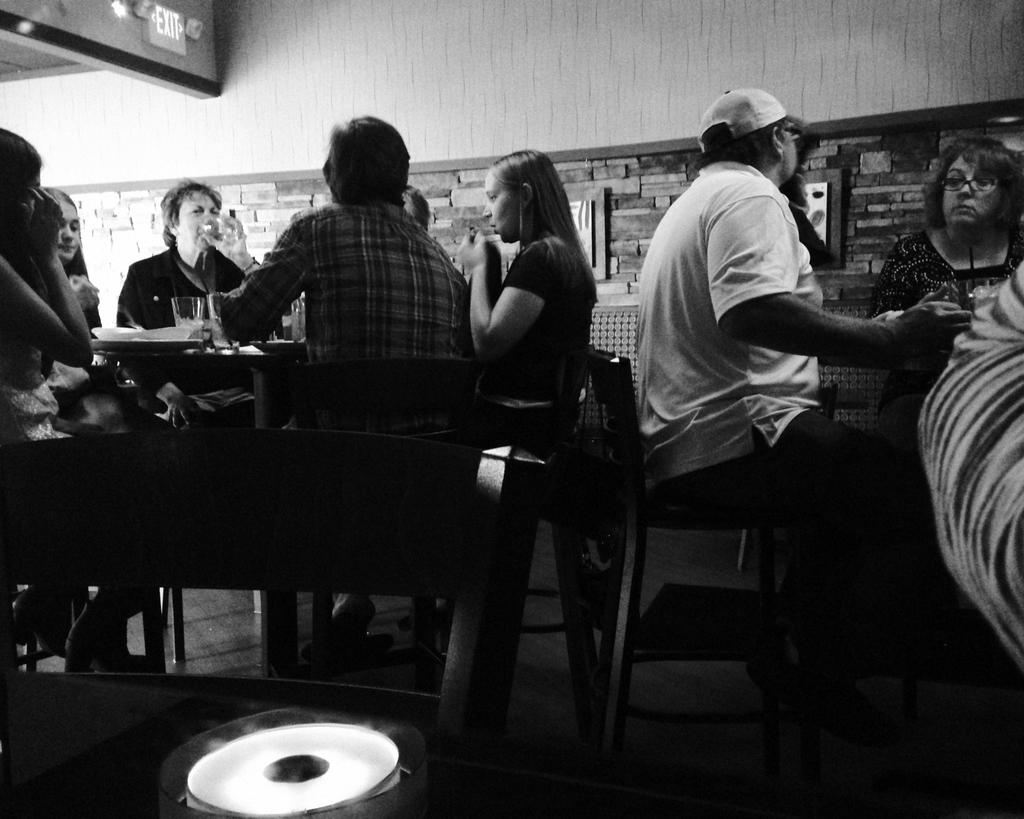What is happening in the image involving a group of people? There is a group of people in the image, and they are seated on chairs. Can you describe any specific actions being performed by someone in the image? Yes, there is a man holding a glass and drinking from it. What type of cream can be seen growing on the plants in the image? There are no plants or cream present in the image; it features a group of people seated on chairs and a man drinking from a glass. 